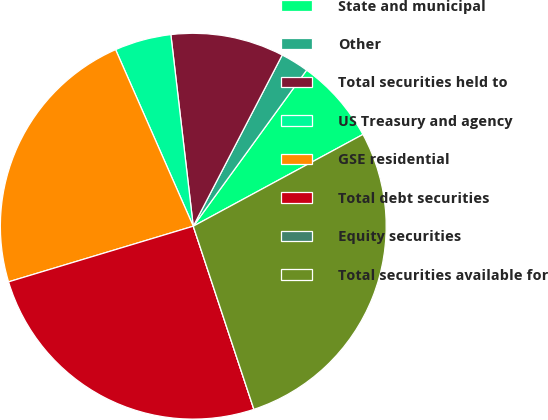Convert chart to OTSL. <chart><loc_0><loc_0><loc_500><loc_500><pie_chart><fcel>State and municipal<fcel>Other<fcel>Total securities held to<fcel>US Treasury and agency<fcel>GSE residential<fcel>Total debt securities<fcel>Equity securities<fcel>Total securities available for<nl><fcel>7.11%<fcel>2.37%<fcel>9.48%<fcel>4.74%<fcel>23.06%<fcel>25.43%<fcel>0.0%<fcel>27.8%<nl></chart> 